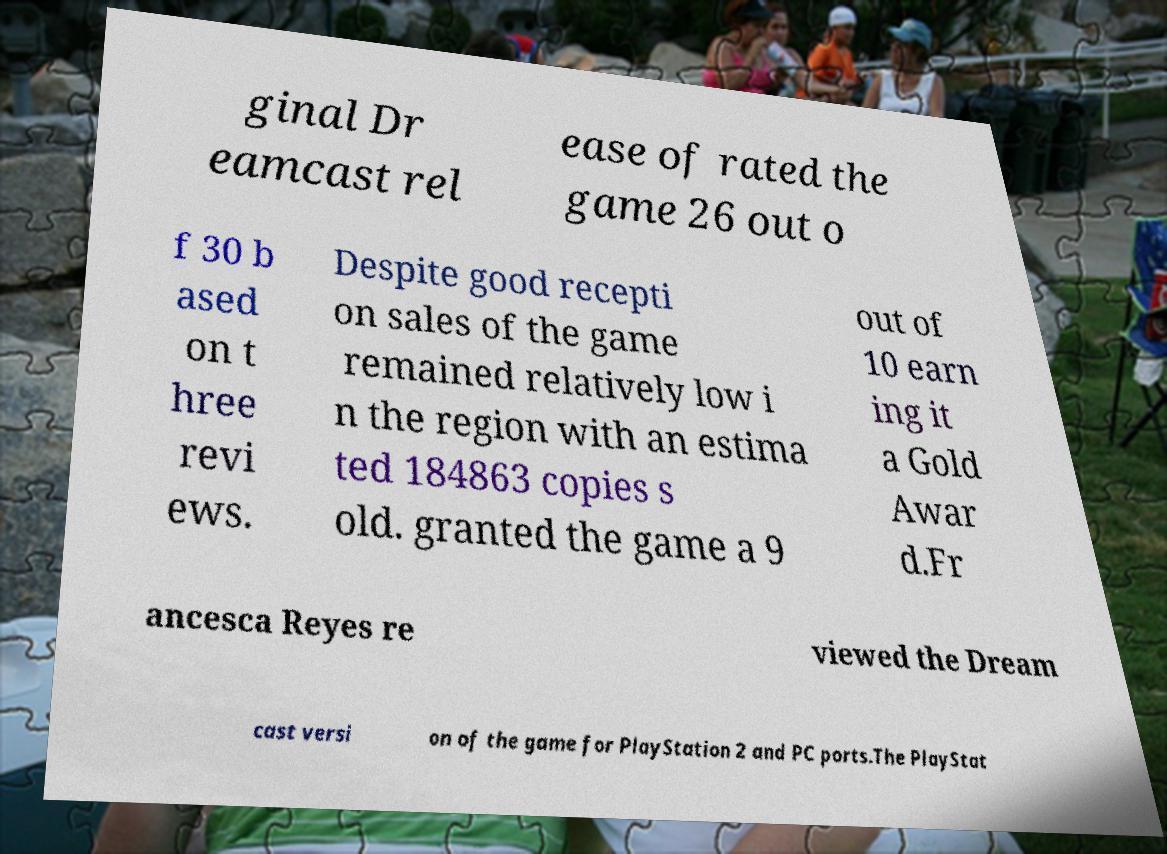Can you accurately transcribe the text from the provided image for me? ginal Dr eamcast rel ease of rated the game 26 out o f 30 b ased on t hree revi ews. Despite good recepti on sales of the game remained relatively low i n the region with an estima ted 184863 copies s old. granted the game a 9 out of 10 earn ing it a Gold Awar d.Fr ancesca Reyes re viewed the Dream cast versi on of the game for PlayStation 2 and PC ports.The PlayStat 